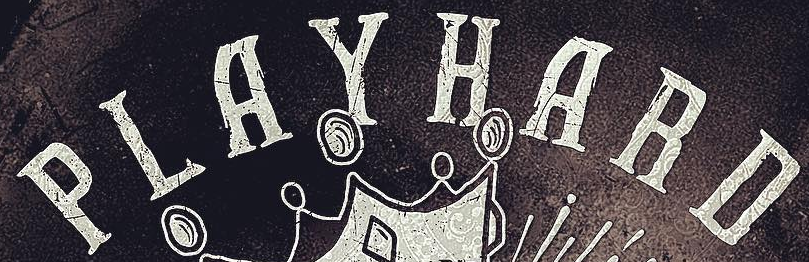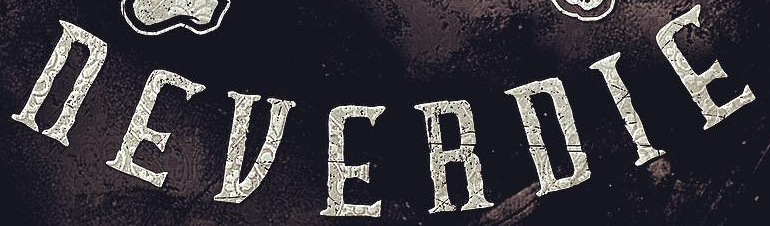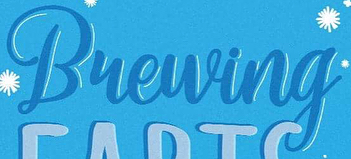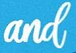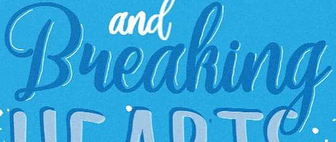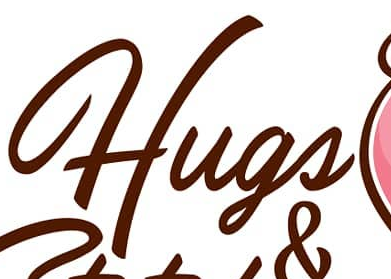What text is displayed in these images sequentially, separated by a semicolon? PLAYHARD; nEVERDIE; Bueuing; and; Bueaking; Hugs 